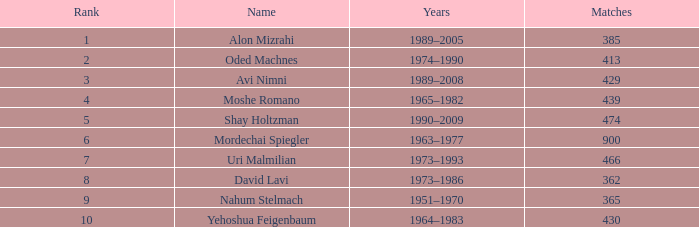What is the Rank of the player with 362 Matches? 8.0. 